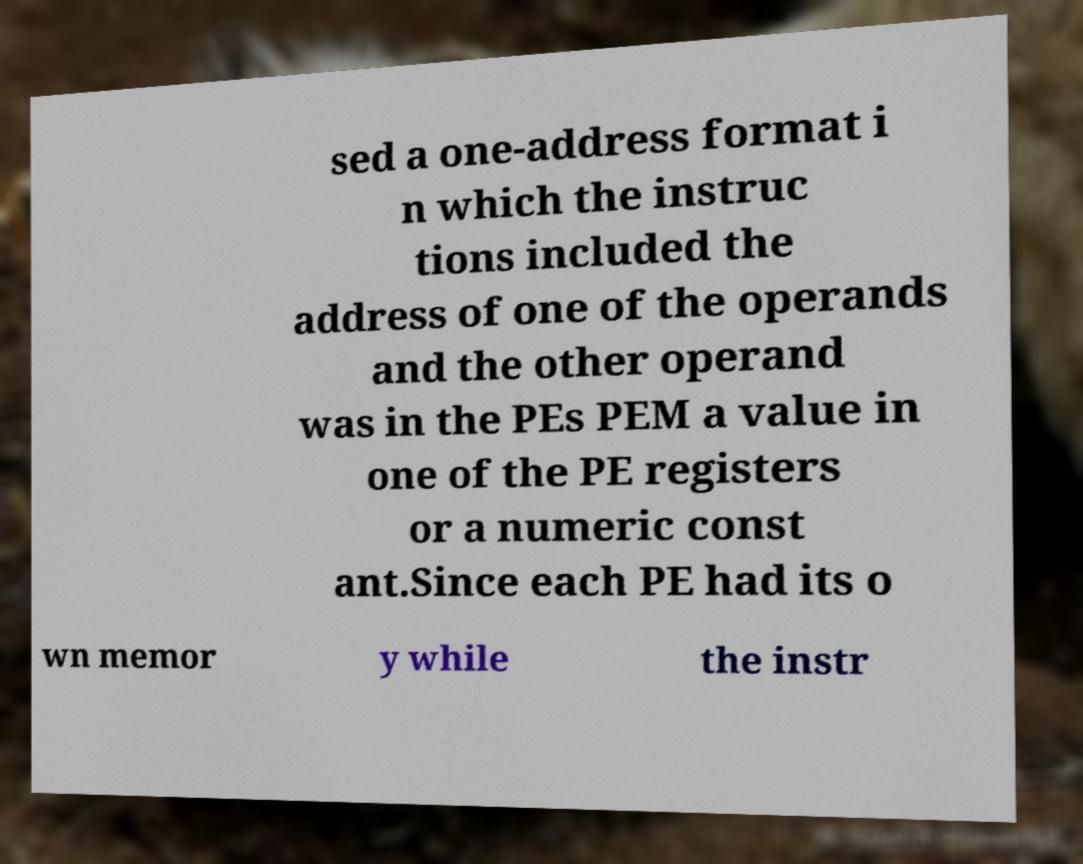For documentation purposes, I need the text within this image transcribed. Could you provide that? sed a one-address format i n which the instruc tions included the address of one of the operands and the other operand was in the PEs PEM a value in one of the PE registers or a numeric const ant.Since each PE had its o wn memor y while the instr 